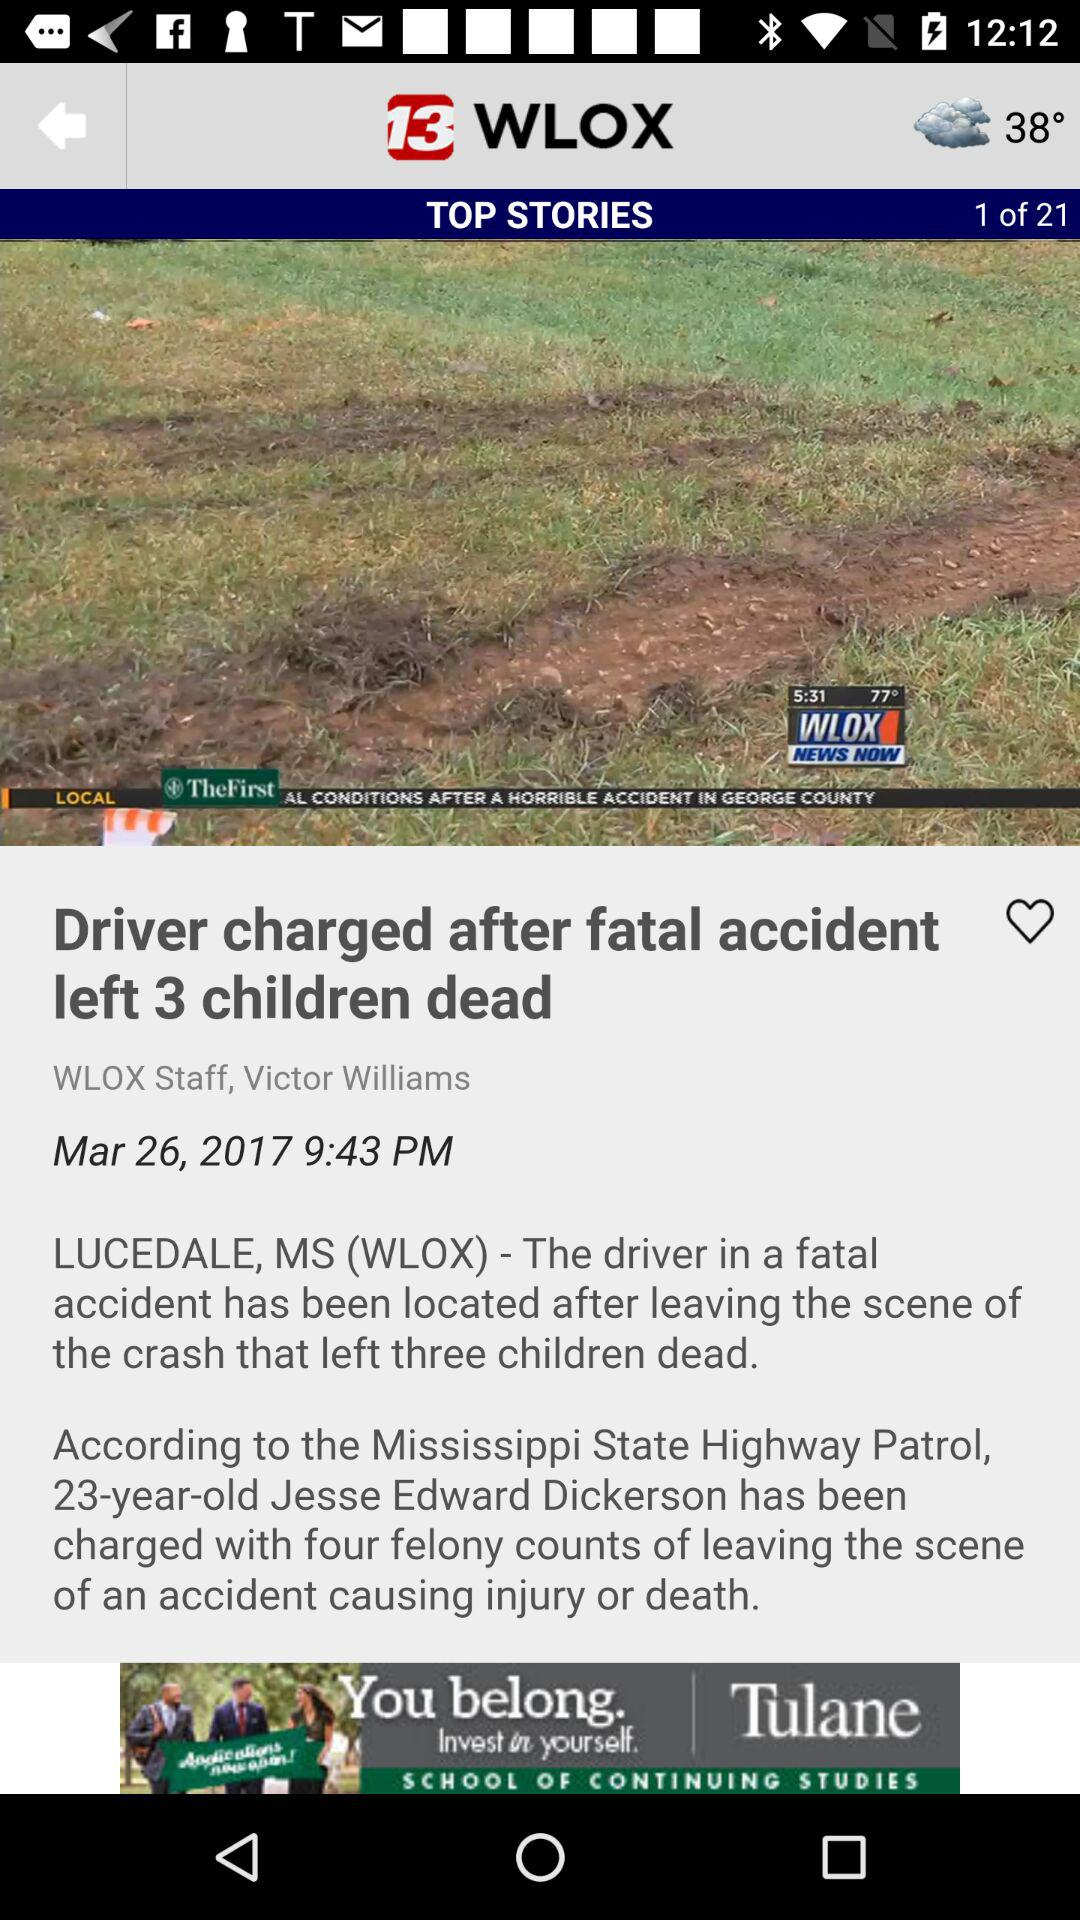What's the total number of top stories? The total number of top stories is 21. 